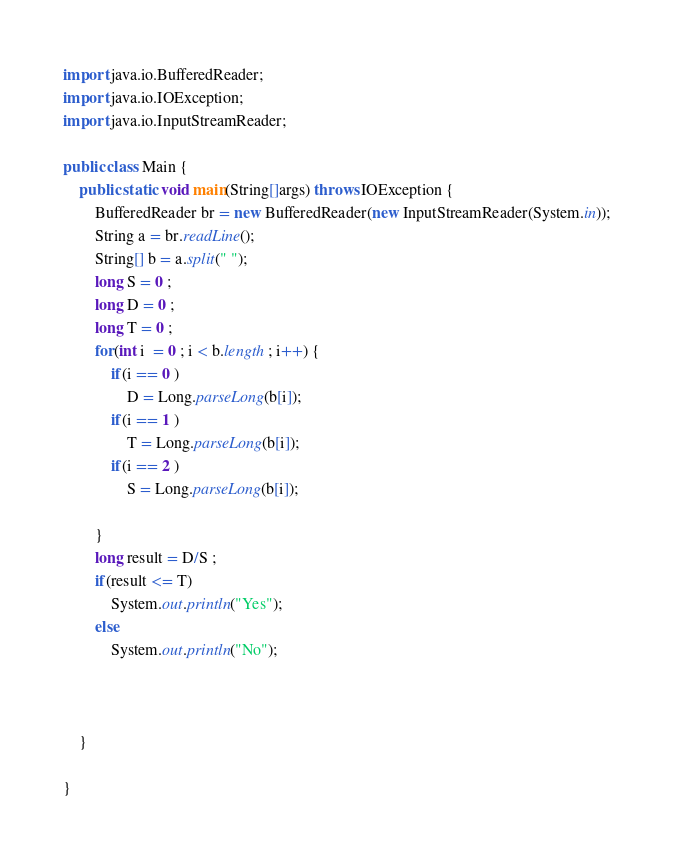Convert code to text. <code><loc_0><loc_0><loc_500><loc_500><_Java_>import java.io.BufferedReader;
import java.io.IOException;
import java.io.InputStreamReader;

public class Main {
	public static void main(String[]args) throws IOException {
		BufferedReader br = new BufferedReader(new InputStreamReader(System.in));
		String a = br.readLine();
		String[] b = a.split(" ");
		long S = 0 ; 
		long D = 0 ;
		long T = 0 ;
		for(int i  = 0 ; i < b.length ; i++) {
			if(i == 0 )
				D = Long.parseLong(b[i]);
			if(i == 1 )
				T = Long.parseLong(b[i]);
			if(i == 2 )
				S = Long.parseLong(b[i]);
			
		}
		long result = D/S ;
		if(result <= T) 
			System.out.println("Yes");
		else
			System.out.println("No");

		
		
	}

}
</code> 